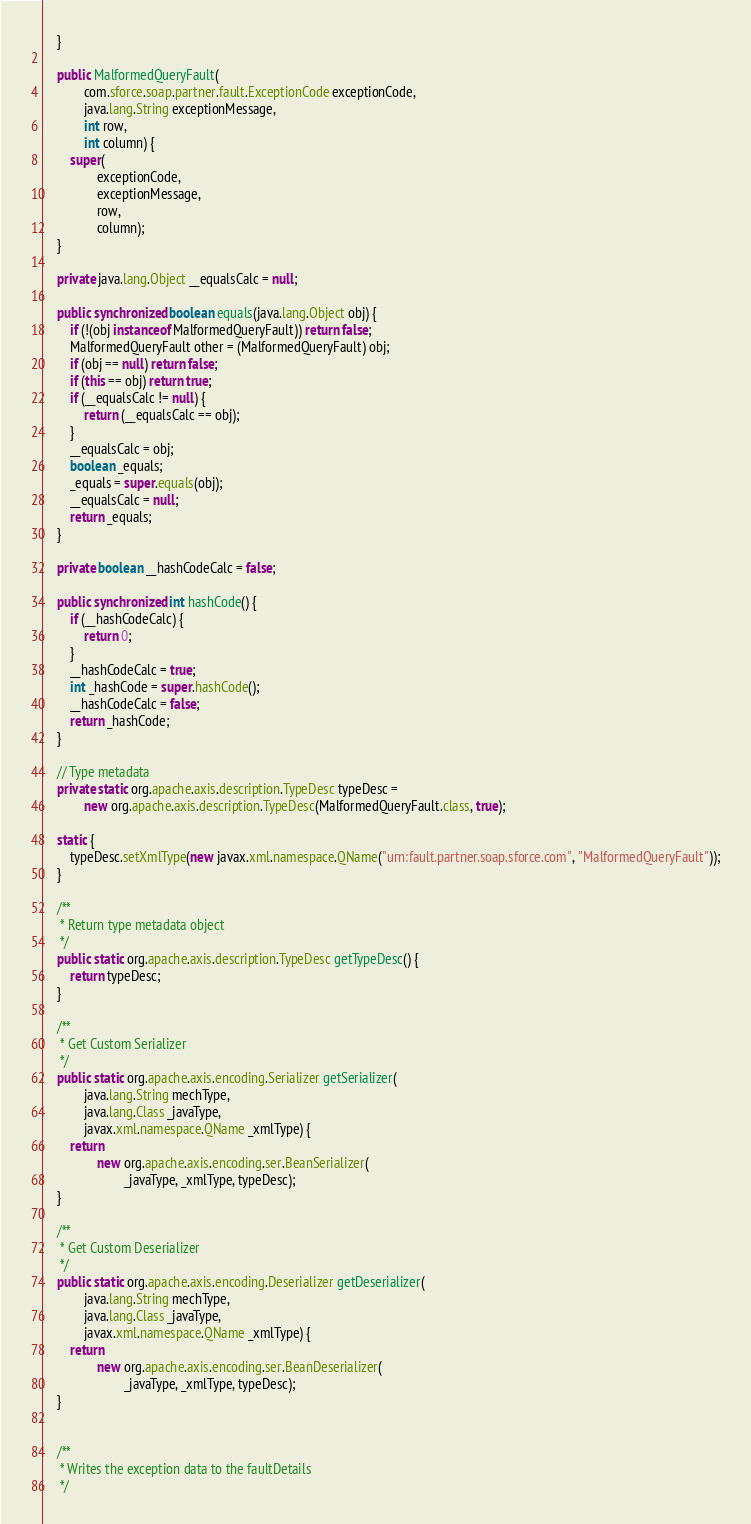Convert code to text. <code><loc_0><loc_0><loc_500><loc_500><_Java_>    }

    public MalformedQueryFault(
            com.sforce.soap.partner.fault.ExceptionCode exceptionCode,
            java.lang.String exceptionMessage,
            int row,
            int column) {
        super(
                exceptionCode,
                exceptionMessage,
                row,
                column);
    }

    private java.lang.Object __equalsCalc = null;

    public synchronized boolean equals(java.lang.Object obj) {
        if (!(obj instanceof MalformedQueryFault)) return false;
        MalformedQueryFault other = (MalformedQueryFault) obj;
        if (obj == null) return false;
        if (this == obj) return true;
        if (__equalsCalc != null) {
            return (__equalsCalc == obj);
        }
        __equalsCalc = obj;
        boolean _equals;
        _equals = super.equals(obj);
        __equalsCalc = null;
        return _equals;
    }

    private boolean __hashCodeCalc = false;

    public synchronized int hashCode() {
        if (__hashCodeCalc) {
            return 0;
        }
        __hashCodeCalc = true;
        int _hashCode = super.hashCode();
        __hashCodeCalc = false;
        return _hashCode;
    }

    // Type metadata
    private static org.apache.axis.description.TypeDesc typeDesc =
            new org.apache.axis.description.TypeDesc(MalformedQueryFault.class, true);

    static {
        typeDesc.setXmlType(new javax.xml.namespace.QName("urn:fault.partner.soap.sforce.com", "MalformedQueryFault"));
    }

    /**
     * Return type metadata object
     */
    public static org.apache.axis.description.TypeDesc getTypeDesc() {
        return typeDesc;
    }

    /**
     * Get Custom Serializer
     */
    public static org.apache.axis.encoding.Serializer getSerializer(
            java.lang.String mechType,
            java.lang.Class _javaType,
            javax.xml.namespace.QName _xmlType) {
        return
                new org.apache.axis.encoding.ser.BeanSerializer(
                        _javaType, _xmlType, typeDesc);
    }

    /**
     * Get Custom Deserializer
     */
    public static org.apache.axis.encoding.Deserializer getDeserializer(
            java.lang.String mechType,
            java.lang.Class _javaType,
            javax.xml.namespace.QName _xmlType) {
        return
                new org.apache.axis.encoding.ser.BeanDeserializer(
                        _javaType, _xmlType, typeDesc);
    }


    /**
     * Writes the exception data to the faultDetails
     */</code> 